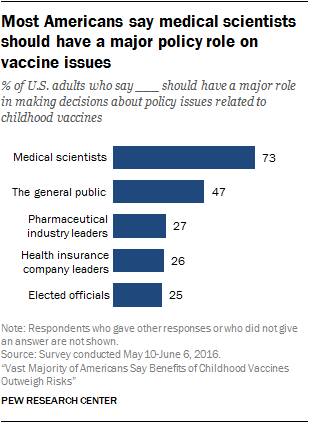Specify some key components in this picture. The value of the Elected officials bar is 25. The average of the two smallest bars is 25.5. 